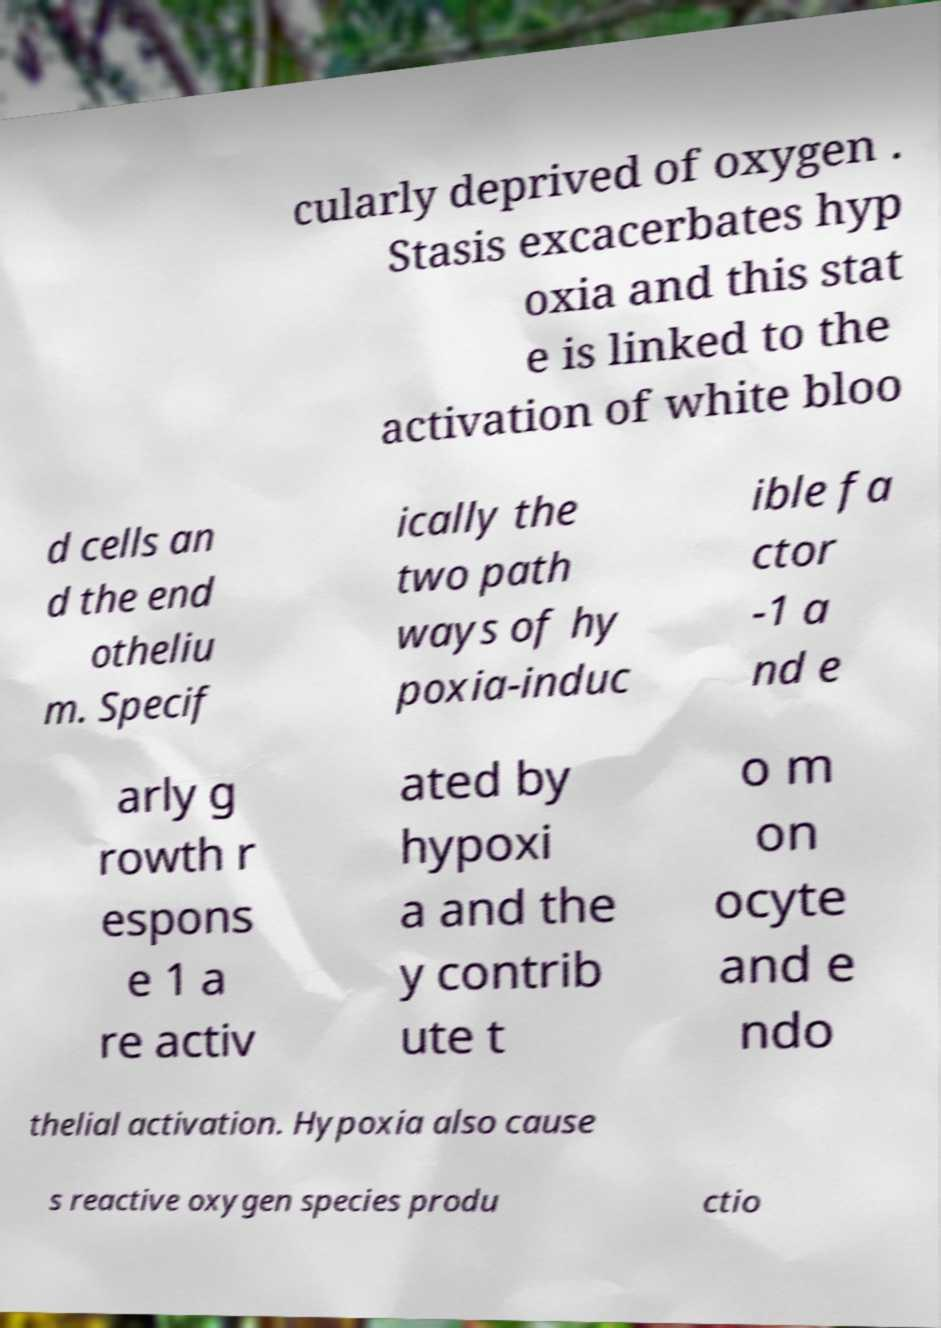Could you assist in decoding the text presented in this image and type it out clearly? cularly deprived of oxygen . Stasis excacerbates hyp oxia and this stat e is linked to the activation of white bloo d cells an d the end otheliu m. Specif ically the two path ways of hy poxia-induc ible fa ctor -1 a nd e arly g rowth r espons e 1 a re activ ated by hypoxi a and the y contrib ute t o m on ocyte and e ndo thelial activation. Hypoxia also cause s reactive oxygen species produ ctio 